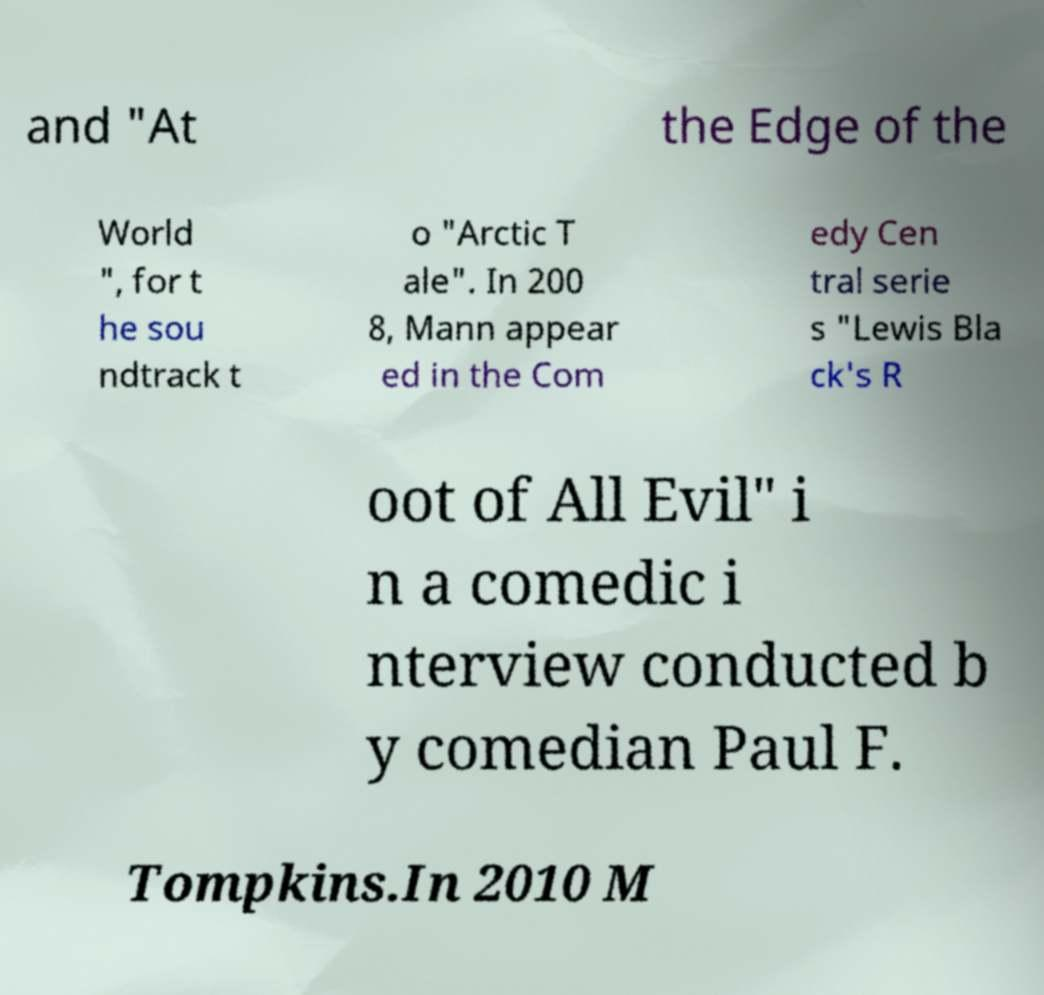For documentation purposes, I need the text within this image transcribed. Could you provide that? and "At the Edge of the World ", for t he sou ndtrack t o "Arctic T ale". In 200 8, Mann appear ed in the Com edy Cen tral serie s "Lewis Bla ck's R oot of All Evil" i n a comedic i nterview conducted b y comedian Paul F. Tompkins.In 2010 M 